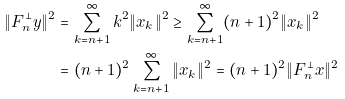<formula> <loc_0><loc_0><loc_500><loc_500>\| F _ { n } ^ { \perp } y \| ^ { 2 } & = \sum _ { k = n + 1 } ^ { \infty } k ^ { 2 } \| x _ { k } \| ^ { 2 } \geq \sum _ { k = n + 1 } ^ { \infty } ( n + 1 ) ^ { 2 } \| x _ { k } \| ^ { 2 } \\ & = ( n + 1 ) ^ { 2 } \sum _ { k = n + 1 } ^ { \infty } \| x _ { k } \| ^ { 2 } = ( n + 1 ) ^ { 2 } \| F _ { n } ^ { \perp } x \| ^ { 2 }</formula> 